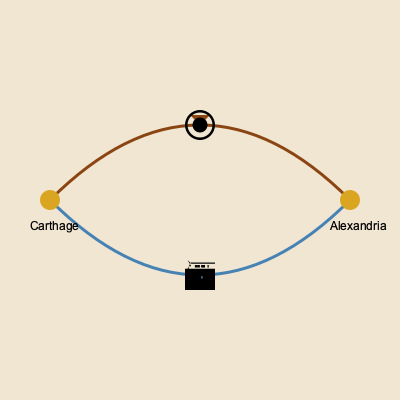Based on the stylized map and iconography provided, which historical trade route is represented, and what were its primary commodities? To identify the historical trade route and its primary commodities, let's analyze the map step-by-step:

1. Cities: The map shows two important ancient cities - Carthage and Alexandria.
   - Carthage was a major Phoenician city-state on the coast of North Africa.
   - Alexandria was a significant Hellenistic city in Egypt, founded by Alexander the Great.

2. Routes: There are two distinct paths connecting these cities.
   - The northern route (brown) appears to be over land.
   - The southern route (blue) likely represents a sea route.

3. Iconography:
   - The sun icon on the northern route suggests a land route, possibly indicating the harsh desert conditions.
   - The ship icon on the southern route confirms it as a maritime path.

4. Historical context:
   - These cities and routes were part of the Mediterranean trade network during the classical and Hellenistic periods (circa 5th-1st centuries BCE).

5. Trade route identification:
   - Given the locations and the time period, this map represents the Phoenician Trade Route.

6. Primary commodities:
   - Phoenicians were known for their purple dye (derived from murex shells), which was highly prized in the ancient world.
   - They also traded in glass, cedar wood, and metalwork.
   - From Egypt (Alexandria), they likely obtained papyrus, grain, and gold.

In conclusion, the map depicts the Phoenician Trade Route, which connected North Africa to Egypt and the wider Mediterranean. The primary commodities would have included Tyrian purple dye, glass, cedar wood, metalwork, papyrus, grain, and gold.
Answer: Phoenician Trade Route; purple dye, glass, cedar, metals, papyrus, grain, gold 